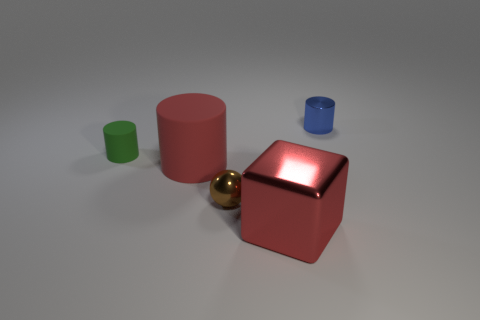Subtract all red cylinders. How many cylinders are left? 2 Subtract 1 cylinders. How many cylinders are left? 2 Add 1 cyan cylinders. How many objects exist? 6 Subtract all cylinders. How many objects are left? 2 Add 1 big yellow cylinders. How many big yellow cylinders exist? 1 Subtract 0 blue cubes. How many objects are left? 5 Subtract all big metallic cubes. Subtract all spheres. How many objects are left? 3 Add 3 small cylinders. How many small cylinders are left? 5 